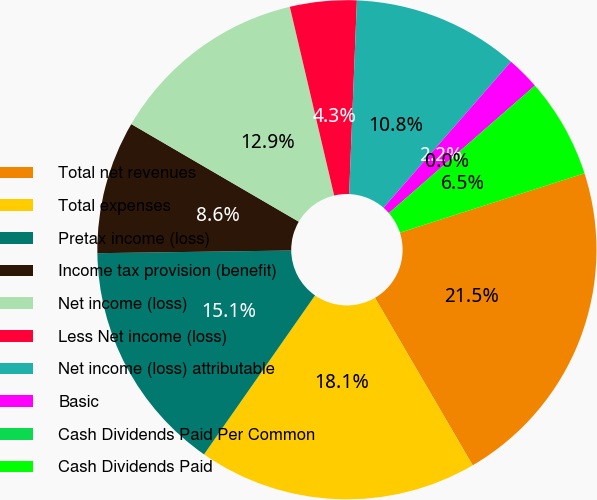<chart> <loc_0><loc_0><loc_500><loc_500><pie_chart><fcel>Total net revenues<fcel>Total expenses<fcel>Pretax income (loss)<fcel>Income tax provision (benefit)<fcel>Net income (loss)<fcel>Less Net income (loss)<fcel>Net income (loss) attributable<fcel>Basic<fcel>Cash Dividends Paid Per Common<fcel>Cash Dividends Paid<nl><fcel>21.55%<fcel>18.11%<fcel>15.08%<fcel>8.62%<fcel>12.93%<fcel>4.31%<fcel>10.78%<fcel>2.16%<fcel>0.0%<fcel>6.47%<nl></chart> 